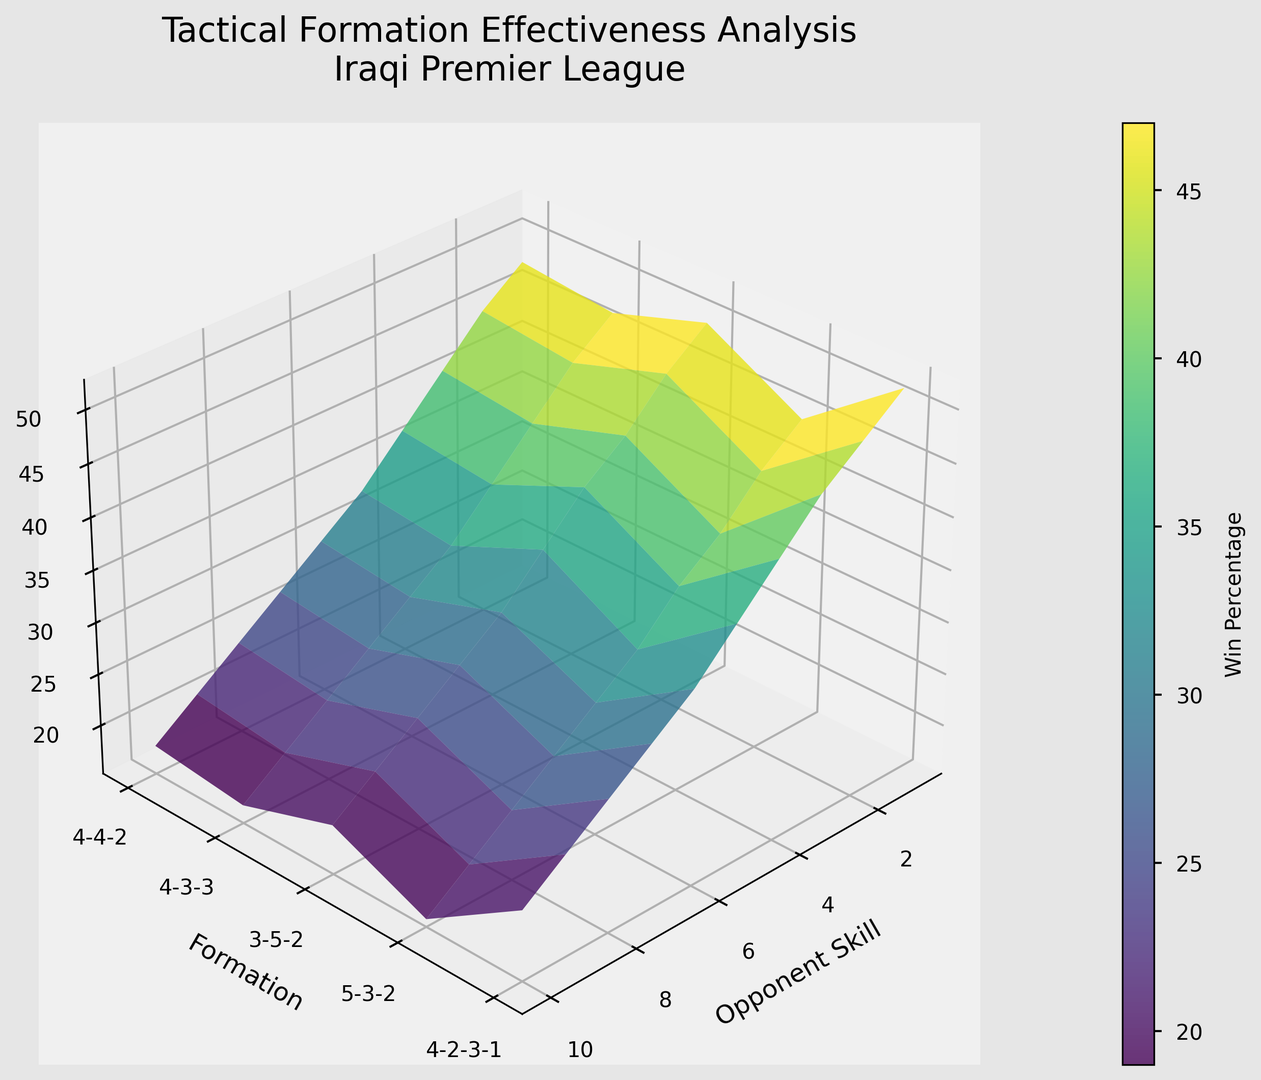What formation has the highest win percentage against the weakest opponents? To find the formation with the highest win percentage against the weakest opponents, locate the data for opponent skill level 1. Among these, the formation with the highest value is 5-3-2 with a win percentage of 52%.
Answer: 5-3-2 Which formation generally performs the best against opponent skill level 5? Look at the win percentages for each formation against opponent skill level 5. The 5-3-2 formation has the highest win percentage at 38%.
Answer: 5-3-2 How does the win percentage of the 4-3-3 formation change from opponent skill level 1 to opponent skill level 10? Track the win percentages for the 4-3-3 formation across all opponent skill levels: 50, 47, 43, 40, 36, 32, 29, 26, 23, and 20. There is a downward trend in win percentage as opponent skill level increases.
Answer: Decreases Between the 4-4-2 and 4-2-3-1 formations, which one has higher win percentages across more opponent skill levels? Compare the win percentages of both formations across all skill levels. Count the number of times each has a higher win percentage. 4-4-2 wins on 5 skill levels (1, 2, 3, 4, 5), whereas 4-2-3-1 does not win on any skill level.
Answer: 4-4-2 Which formation shows the least decrease in win percentage from opponent skill level 1 to level 5? Calculate the decrease in win percentage for each formation from level 1 to level 5: 4-4-2 drops 14%, 4-3-3 drops 14%, 3-5-2 drops 15%, 5-3-2 drops 14%, 4-2-3-1 drops 15%. The decrease is similar for 4-4-2, 4-3-3, and 5-3-2, but none differ significantly so any could be considered correct.
Answer: 4-4-2, 4-3-3, or 5-3-2 Which formation maintains the highest win percentage against mid-level opponents (e.g., skill level 5 and 6)? Look at the data for opponent skill levels 5 and 6. The 5-3-2 formation has the highest win percentages at 38% (level 5) and 34% (level 6).
Answer: 5-3-2 What is the average win percentage of the 3-5-2 formation across all opponent skill levels? Calculate the average of the win percentages for the 3-5-2 formation: (48 + 45 + 41 + 37 + 33 + 30 + 27 + 24 + 21 + 18) / 10 = 324 / 10.
Answer: 32.4 How does the win percentage of the 5-3-2 formation compare to the 4-2-3-1 formation against the highest-level opponents (e.g., skill level 9 and 10)? Compare the specific win percentages: at skill level 9, 5-3-2 has 25% and 4-2-3-1 has 20%; at skill level 10, 5-3-2 has 22% and 4-2-3-1 has 17%. In both cases, the 5-3-2 formation has higher win percentages.
Answer: 5-3-2 is higher Which formation's performance degrades the fastest as the opponent skill level increases, judging by the steepness of the surface plot? Observe the steepness of the decline in win percentages across opponent skill levels for each formation. The 4-2-3-1 formation seems to degrade the fastest as the opponent skill level increases, showing a rapid decrease in win percentage.
Answer: 4-2-3-1 